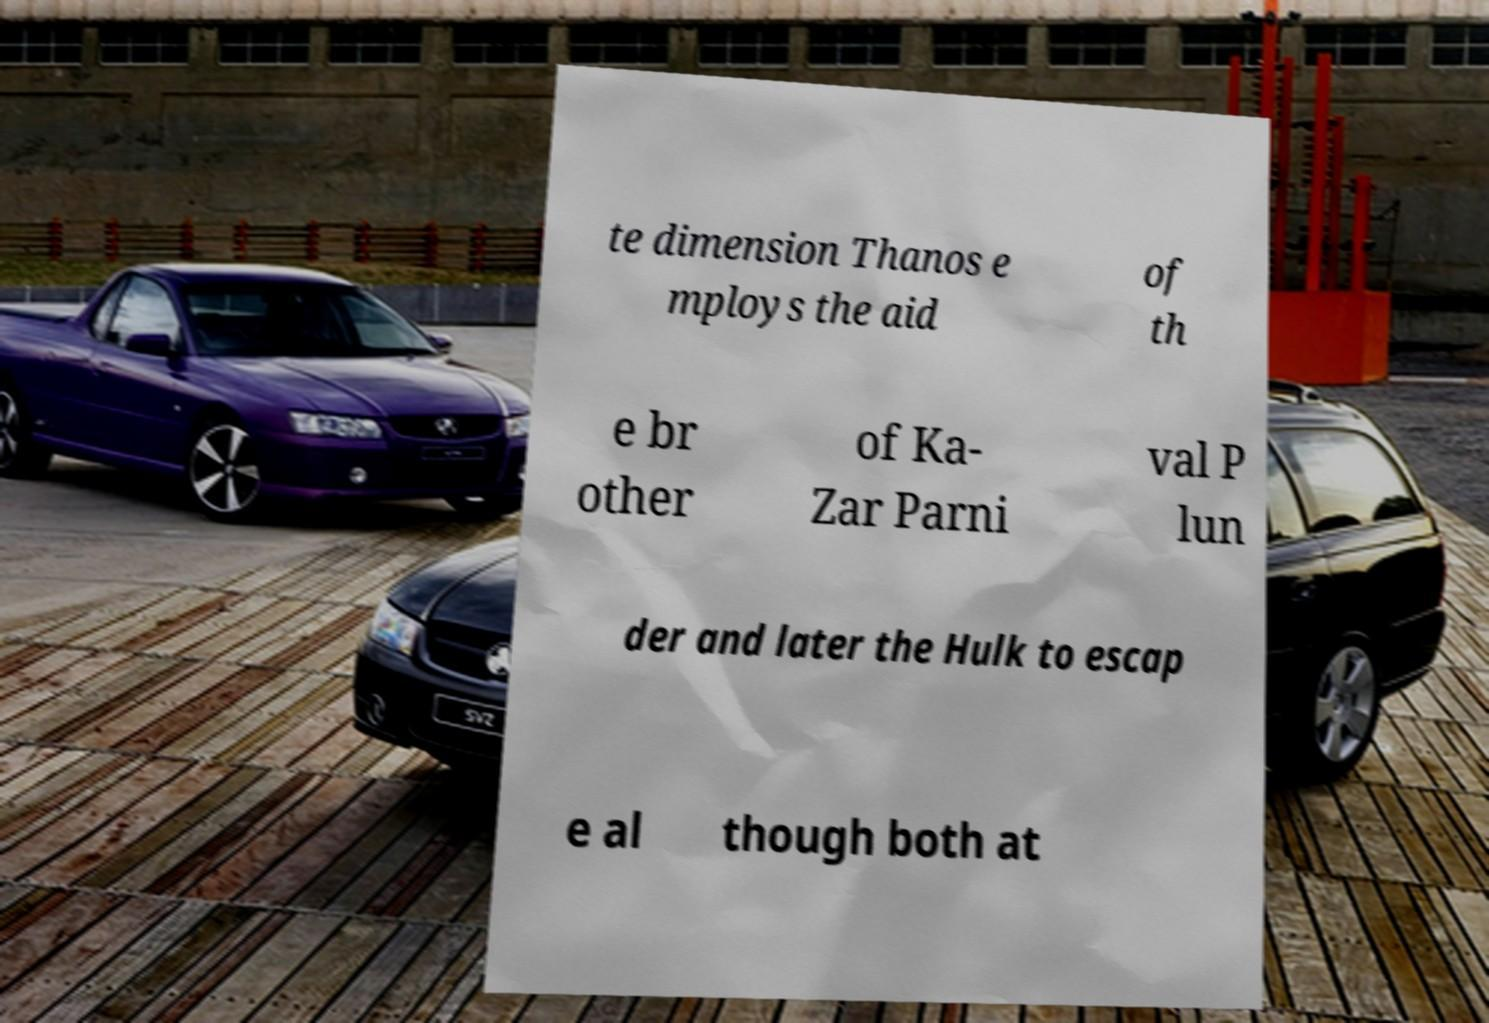Can you accurately transcribe the text from the provided image for me? te dimension Thanos e mploys the aid of th e br other of Ka- Zar Parni val P lun der and later the Hulk to escap e al though both at 